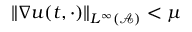<formula> <loc_0><loc_0><loc_500><loc_500>\| \nabla u ( t , \cdot ) \| _ { L ^ { \infty } ( \mathcal { A } ) } < \mu</formula> 